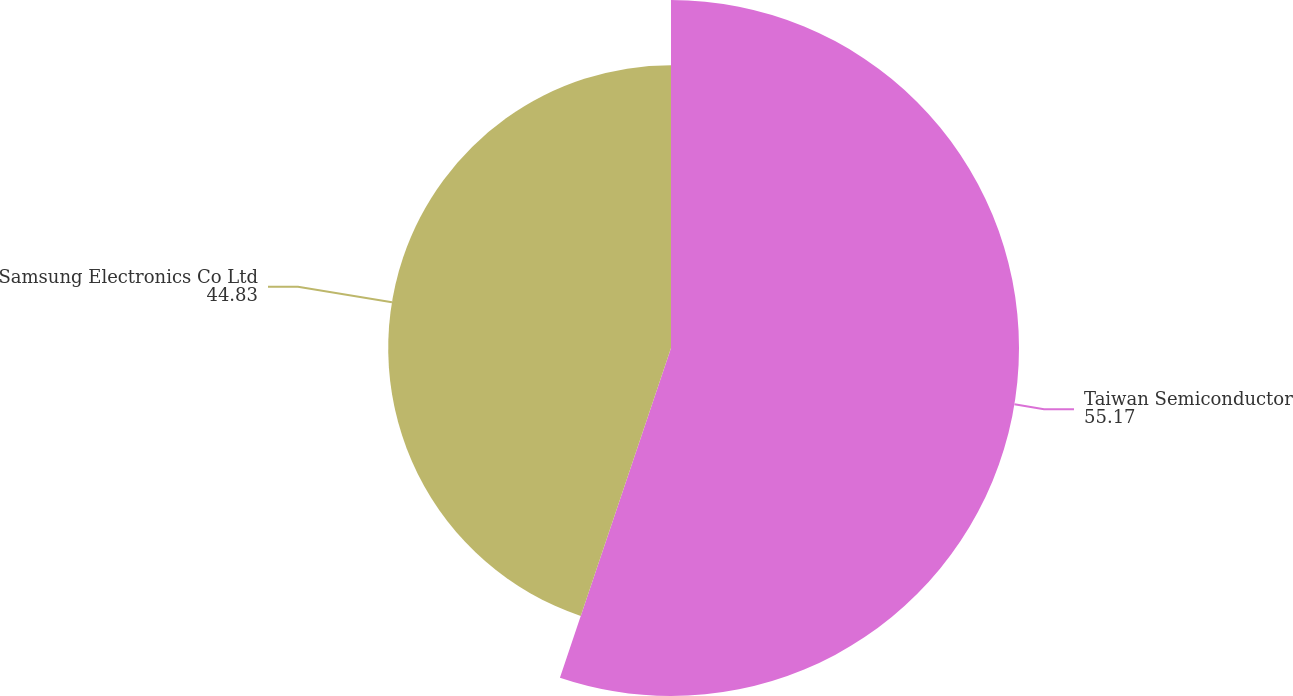Convert chart. <chart><loc_0><loc_0><loc_500><loc_500><pie_chart><fcel>Taiwan Semiconductor<fcel>Samsung Electronics Co Ltd<nl><fcel>55.17%<fcel>44.83%<nl></chart> 